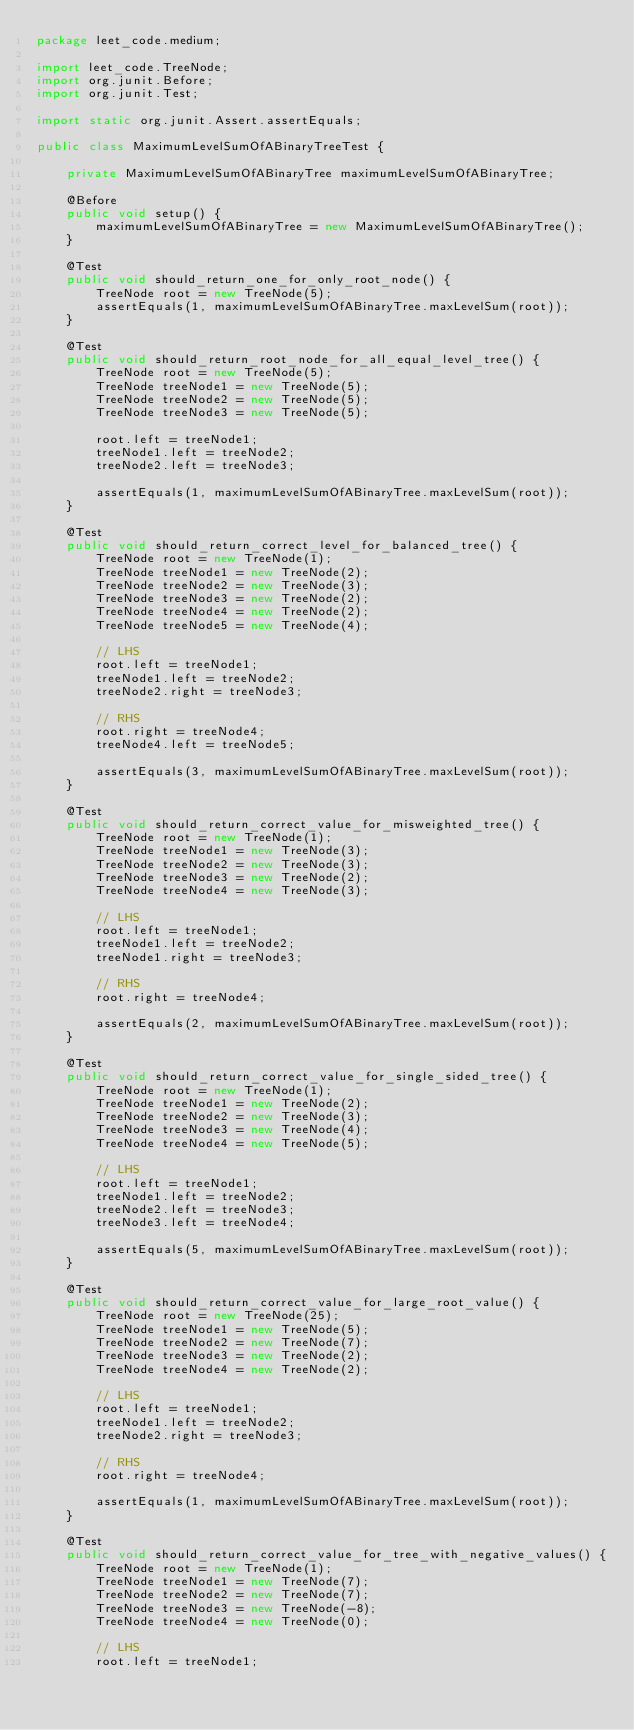Convert code to text. <code><loc_0><loc_0><loc_500><loc_500><_Java_>package leet_code.medium;

import leet_code.TreeNode;
import org.junit.Before;
import org.junit.Test;

import static org.junit.Assert.assertEquals;

public class MaximumLevelSumOfABinaryTreeTest {

    private MaximumLevelSumOfABinaryTree maximumLevelSumOfABinaryTree;

    @Before
    public void setup() {
        maximumLevelSumOfABinaryTree = new MaximumLevelSumOfABinaryTree();
    }

    @Test
    public void should_return_one_for_only_root_node() {
        TreeNode root = new TreeNode(5);
        assertEquals(1, maximumLevelSumOfABinaryTree.maxLevelSum(root));
    }

    @Test
    public void should_return_root_node_for_all_equal_level_tree() {
        TreeNode root = new TreeNode(5);
        TreeNode treeNode1 = new TreeNode(5);
        TreeNode treeNode2 = new TreeNode(5);
        TreeNode treeNode3 = new TreeNode(5);

        root.left = treeNode1;
        treeNode1.left = treeNode2;
        treeNode2.left = treeNode3;

        assertEquals(1, maximumLevelSumOfABinaryTree.maxLevelSum(root));
    }

    @Test
    public void should_return_correct_level_for_balanced_tree() {
        TreeNode root = new TreeNode(1);
        TreeNode treeNode1 = new TreeNode(2);
        TreeNode treeNode2 = new TreeNode(3);
        TreeNode treeNode3 = new TreeNode(2);
        TreeNode treeNode4 = new TreeNode(2);
        TreeNode treeNode5 = new TreeNode(4);

        // LHS
        root.left = treeNode1;
        treeNode1.left = treeNode2;
        treeNode2.right = treeNode3;

        // RHS
        root.right = treeNode4;
        treeNode4.left = treeNode5;

        assertEquals(3, maximumLevelSumOfABinaryTree.maxLevelSum(root));
    }

    @Test
    public void should_return_correct_value_for_misweighted_tree() {
        TreeNode root = new TreeNode(1);
        TreeNode treeNode1 = new TreeNode(3);
        TreeNode treeNode2 = new TreeNode(3);
        TreeNode treeNode3 = new TreeNode(2);
        TreeNode treeNode4 = new TreeNode(3);

        // LHS
        root.left = treeNode1;
        treeNode1.left = treeNode2;
        treeNode1.right = treeNode3;

        // RHS
        root.right = treeNode4;

        assertEquals(2, maximumLevelSumOfABinaryTree.maxLevelSum(root));
    }

    @Test
    public void should_return_correct_value_for_single_sided_tree() {
        TreeNode root = new TreeNode(1);
        TreeNode treeNode1 = new TreeNode(2);
        TreeNode treeNode2 = new TreeNode(3);
        TreeNode treeNode3 = new TreeNode(4);
        TreeNode treeNode4 = new TreeNode(5);

        // LHS
        root.left = treeNode1;
        treeNode1.left = treeNode2;
        treeNode2.left = treeNode3;
        treeNode3.left = treeNode4;

        assertEquals(5, maximumLevelSumOfABinaryTree.maxLevelSum(root));
    }

    @Test
    public void should_return_correct_value_for_large_root_value() {
        TreeNode root = new TreeNode(25);
        TreeNode treeNode1 = new TreeNode(5);
        TreeNode treeNode2 = new TreeNode(7);
        TreeNode treeNode3 = new TreeNode(2);
        TreeNode treeNode4 = new TreeNode(2);

        // LHS
        root.left = treeNode1;
        treeNode1.left = treeNode2;
        treeNode2.right = treeNode3;

        // RHS
        root.right = treeNode4;

        assertEquals(1, maximumLevelSumOfABinaryTree.maxLevelSum(root));
    }

    @Test
    public void should_return_correct_value_for_tree_with_negative_values() {
        TreeNode root = new TreeNode(1);
        TreeNode treeNode1 = new TreeNode(7);
        TreeNode treeNode2 = new TreeNode(7);
        TreeNode treeNode3 = new TreeNode(-8);
        TreeNode treeNode4 = new TreeNode(0);

        // LHS
        root.left = treeNode1;</code> 